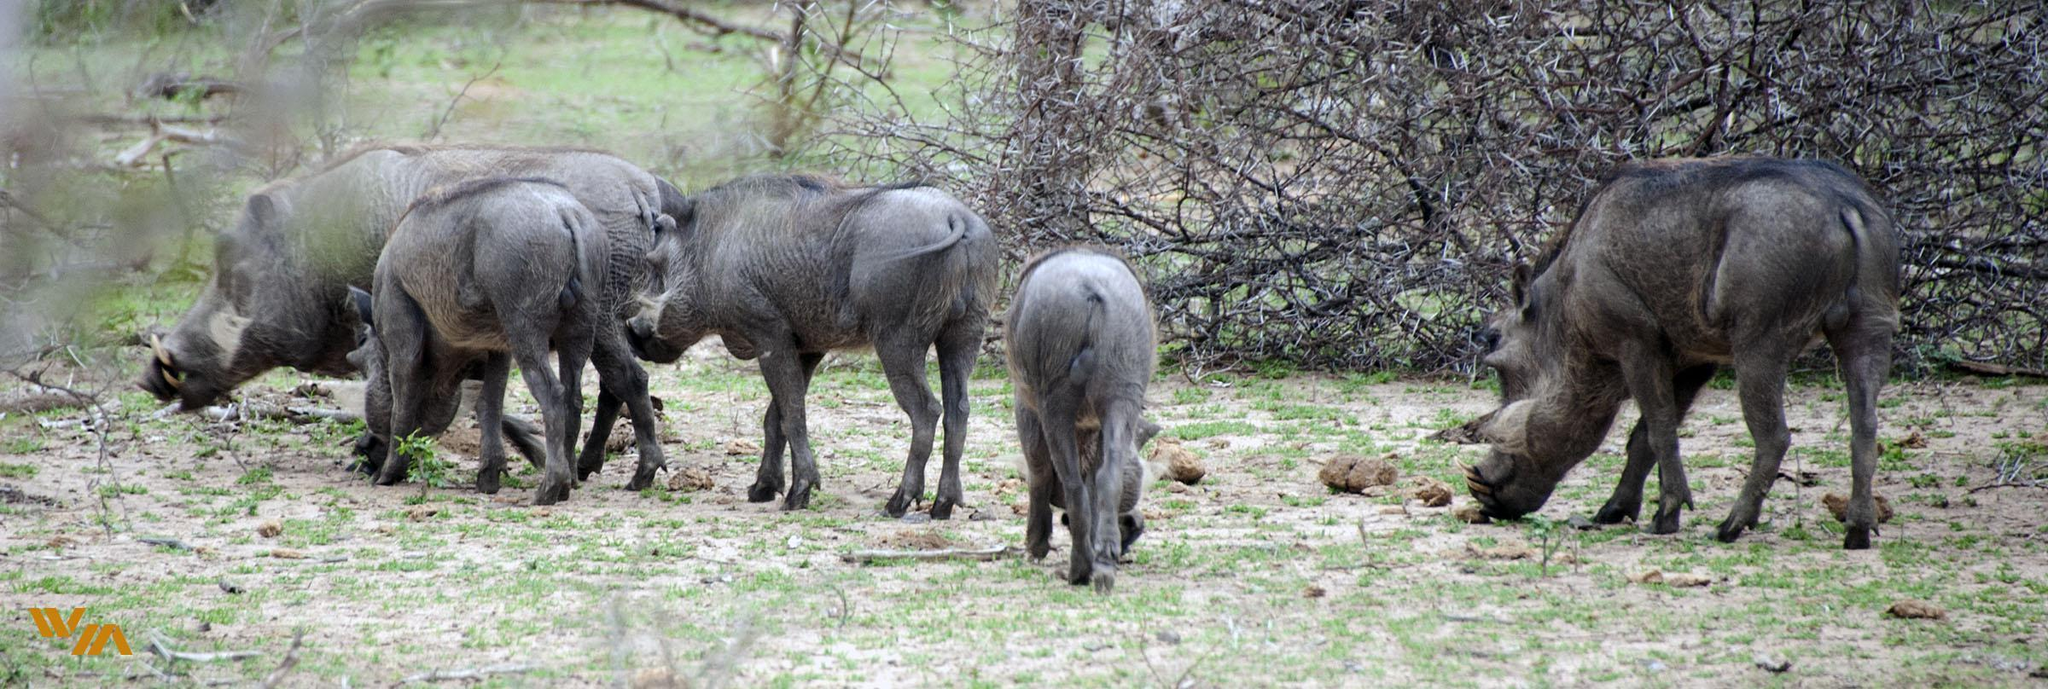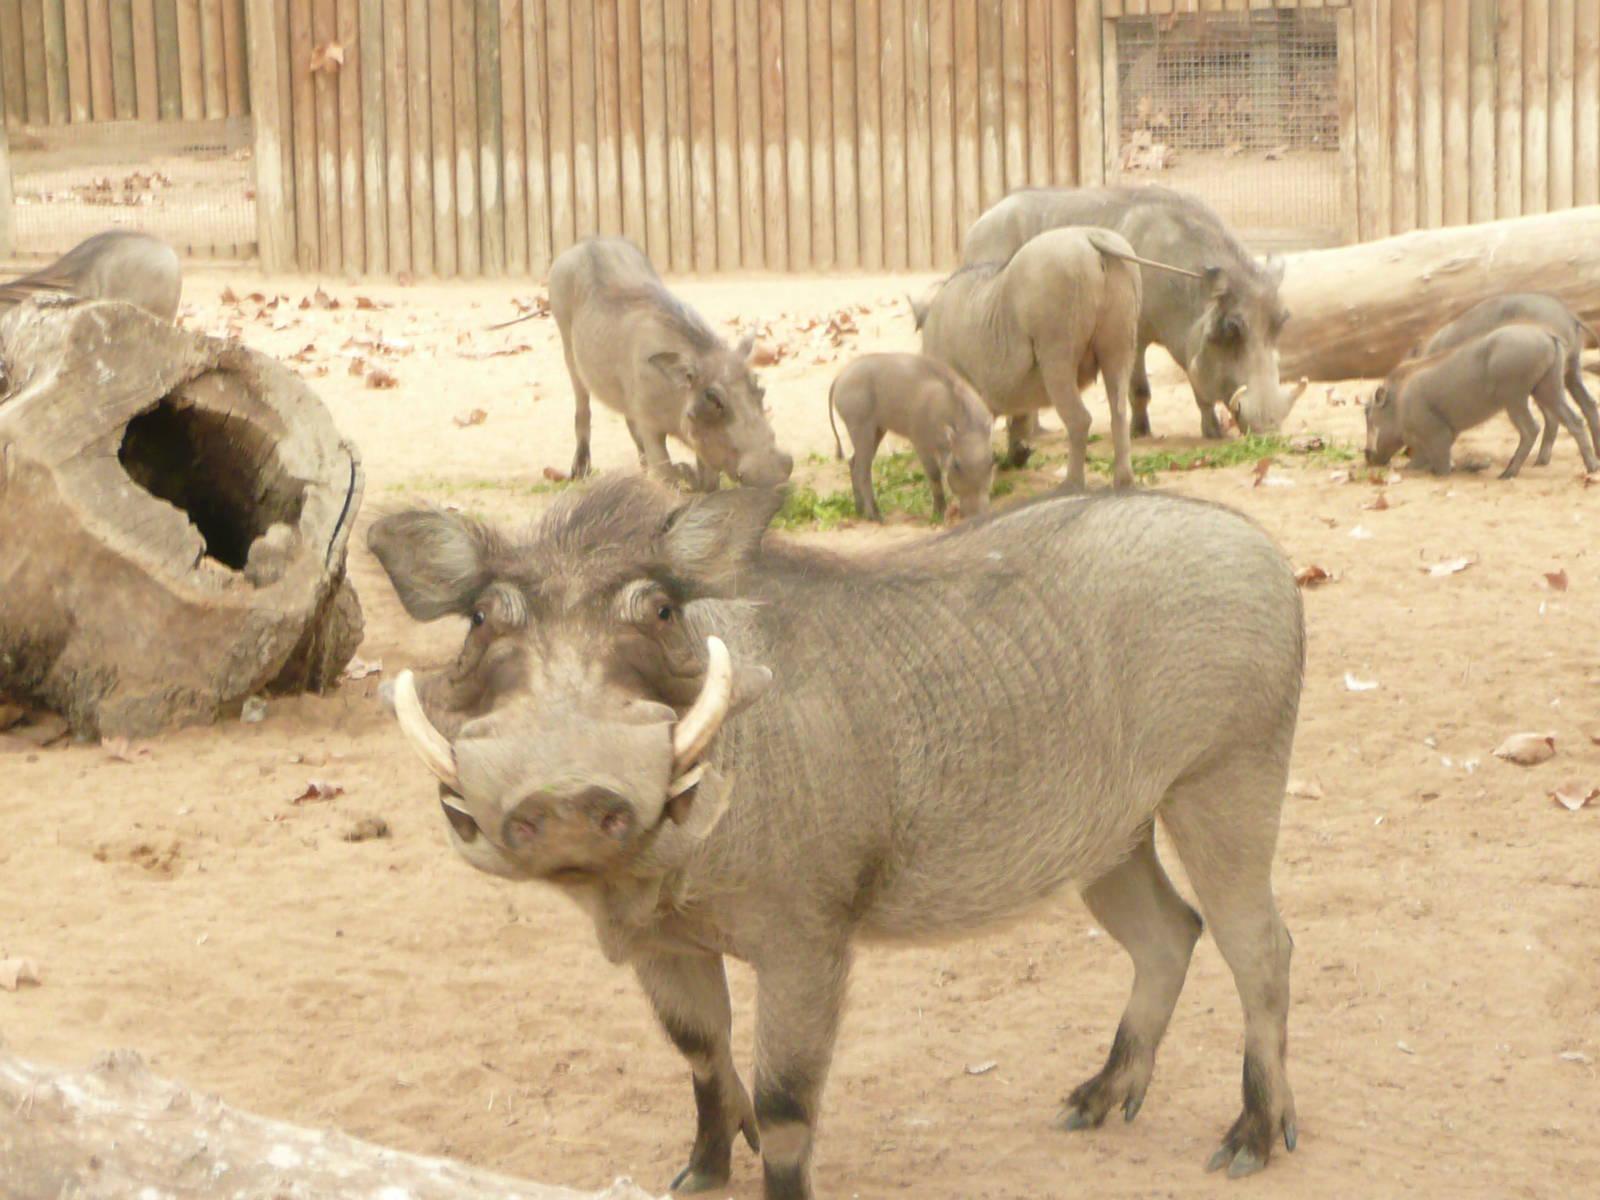The first image is the image on the left, the second image is the image on the right. Examine the images to the left and right. Is the description "There are five warthogs in the left image." accurate? Answer yes or no. Yes. 